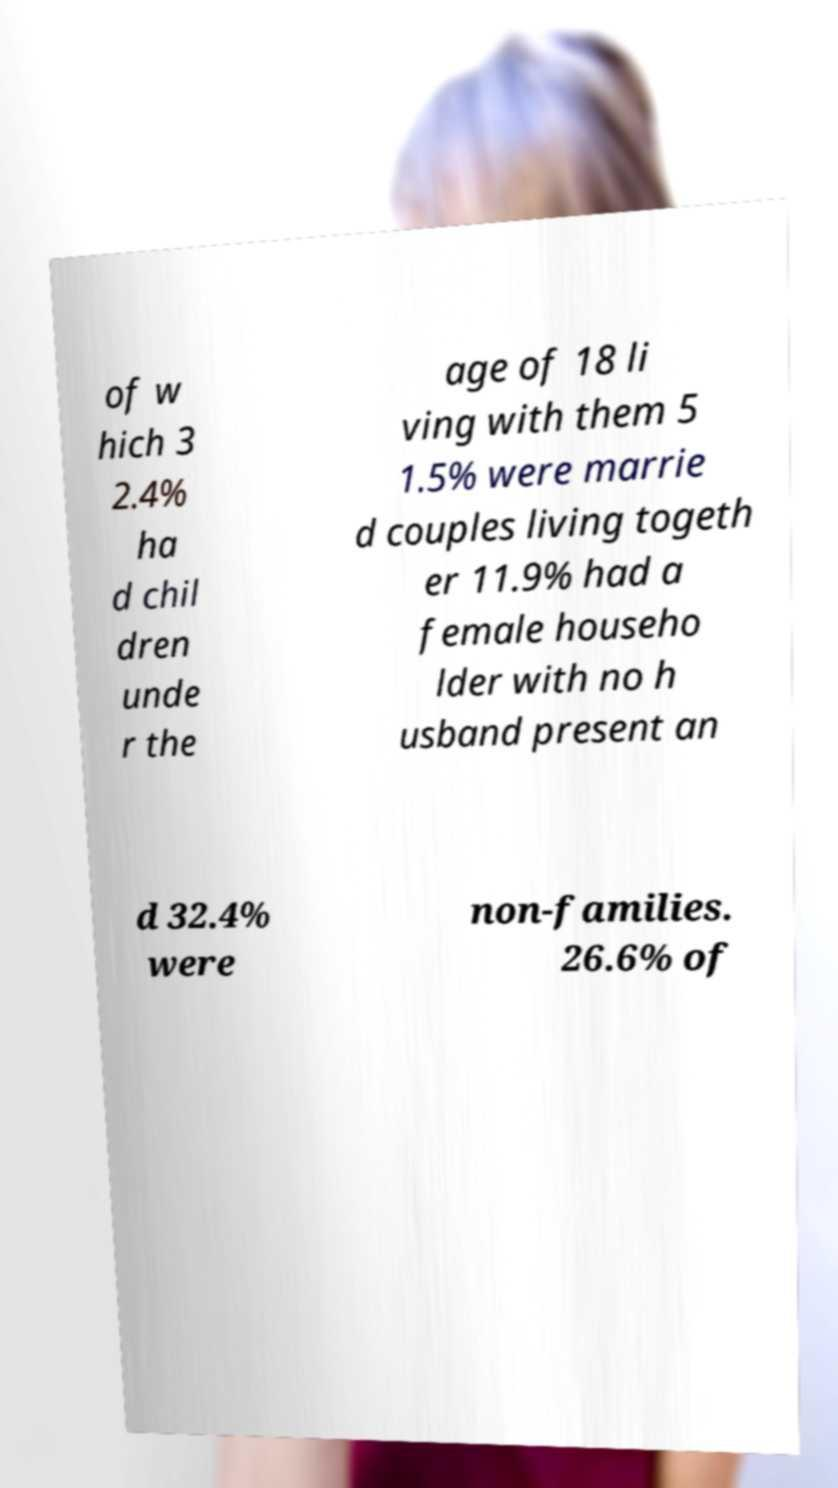Could you extract and type out the text from this image? of w hich 3 2.4% ha d chil dren unde r the age of 18 li ving with them 5 1.5% were marrie d couples living togeth er 11.9% had a female househo lder with no h usband present an d 32.4% were non-families. 26.6% of 